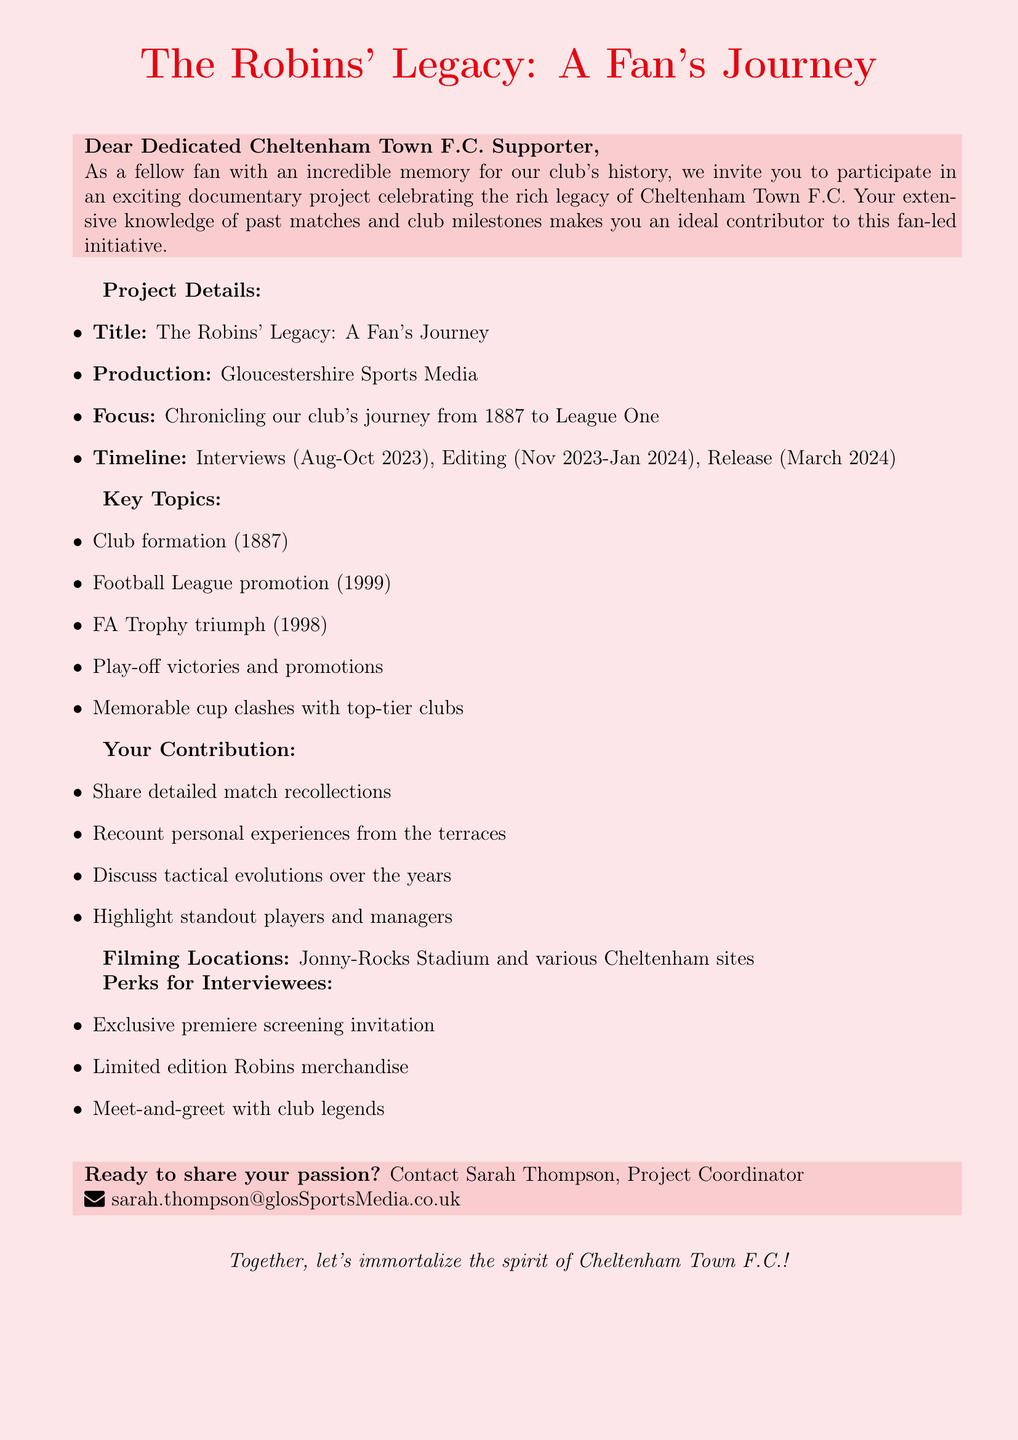What is the project name? The project name is specified at the beginning of the document.
Answer: The Robins' Legacy: A Fan's Journey Who is the production company? The document lists this in the project details section.
Answer: Gloucestershire Sports Media What year was the club formed? This information is included in the key topics list.
Answer: 1887 What is the release date of the documentary? The release date is mentioned in the project timeline section.
Answer: March 2024 What major trophy did Cheltenham Town F.C. win in 1998? It's highlighted in the key topics of the document.
Answer: FA Trophy Which stadium is mentioned as a filming location? This is specified in the filming locations section.
Answer: Jonny-Rocks Stadium What perks are offered to interviewees? The document lists these benefits under a dedicated section.
Answer: Exclusive screening invitation What is the contact person's name? The contact person's name is provided at the end of the document.
Answer: Sarah Thompson What time frame is allocated for interviews? This is included in the project timeline.
Answer: August - October 2023 